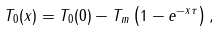<formula> <loc_0><loc_0><loc_500><loc_500>T _ { 0 } ( x ) = T _ { 0 } ( 0 ) - T _ { m } \left ( 1 - e ^ { - x \tau } \right ) ,</formula> 